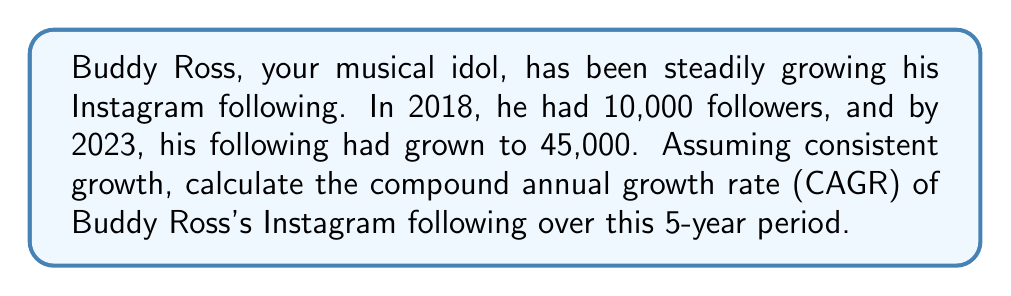Show me your answer to this math problem. To calculate the Compound Annual Growth Rate (CAGR), we use the following formula:

$$ CAGR = \left(\frac{Ending Value}{Beginning Value}\right)^{\frac{1}{n}} - 1 $$

Where:
- Ending Value = 45,000 followers
- Beginning Value = 10,000 followers
- n = 5 years

Let's substitute these values into the formula:

$$ CAGR = \left(\frac{45,000}{10,000}\right)^{\frac{1}{5}} - 1 $$

$$ CAGR = (4.5)^{0.2} - 1 $$

Now, let's calculate this step-by-step:

1. Calculate $4.5^{0.2}$:
   $4.5^{0.2} \approx 1.3512$

2. Subtract 1:
   $1.3512 - 1 = 0.3512$

3. Convert to a percentage:
   $0.3512 \times 100 \approx 35.12\%$

Therefore, the Compound Annual Growth Rate of Buddy Ross's Instagram following over the 5-year period is approximately 35.12%.
Answer: 35.12% 